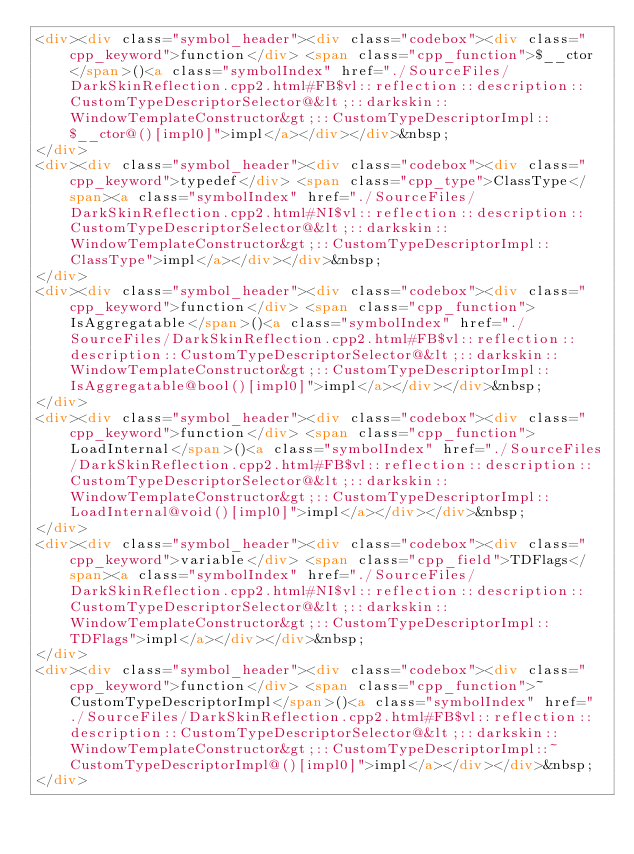Convert code to text. <code><loc_0><loc_0><loc_500><loc_500><_HTML_><div><div class="symbol_header"><div class="codebox"><div class="cpp_keyword">function</div> <span class="cpp_function">$__ctor</span>()<a class="symbolIndex" href="./SourceFiles/DarkSkinReflection.cpp2.html#FB$vl::reflection::description::CustomTypeDescriptorSelector@&lt;::darkskin::WindowTemplateConstructor&gt;::CustomTypeDescriptorImpl::$__ctor@()[impl0]">impl</a></div></div>&nbsp;
</div>
<div><div class="symbol_header"><div class="codebox"><div class="cpp_keyword">typedef</div> <span class="cpp_type">ClassType</span><a class="symbolIndex" href="./SourceFiles/DarkSkinReflection.cpp2.html#NI$vl::reflection::description::CustomTypeDescriptorSelector@&lt;::darkskin::WindowTemplateConstructor&gt;::CustomTypeDescriptorImpl::ClassType">impl</a></div></div>&nbsp;
</div>
<div><div class="symbol_header"><div class="codebox"><div class="cpp_keyword">function</div> <span class="cpp_function">IsAggregatable</span>()<a class="symbolIndex" href="./SourceFiles/DarkSkinReflection.cpp2.html#FB$vl::reflection::description::CustomTypeDescriptorSelector@&lt;::darkskin::WindowTemplateConstructor&gt;::CustomTypeDescriptorImpl::IsAggregatable@bool()[impl0]">impl</a></div></div>&nbsp;
</div>
<div><div class="symbol_header"><div class="codebox"><div class="cpp_keyword">function</div> <span class="cpp_function">LoadInternal</span>()<a class="symbolIndex" href="./SourceFiles/DarkSkinReflection.cpp2.html#FB$vl::reflection::description::CustomTypeDescriptorSelector@&lt;::darkskin::WindowTemplateConstructor&gt;::CustomTypeDescriptorImpl::LoadInternal@void()[impl0]">impl</a></div></div>&nbsp;
</div>
<div><div class="symbol_header"><div class="codebox"><div class="cpp_keyword">variable</div> <span class="cpp_field">TDFlags</span><a class="symbolIndex" href="./SourceFiles/DarkSkinReflection.cpp2.html#NI$vl::reflection::description::CustomTypeDescriptorSelector@&lt;::darkskin::WindowTemplateConstructor&gt;::CustomTypeDescriptorImpl::TDFlags">impl</a></div></div>&nbsp;
</div>
<div><div class="symbol_header"><div class="codebox"><div class="cpp_keyword">function</div> <span class="cpp_function">~CustomTypeDescriptorImpl</span>()<a class="symbolIndex" href="./SourceFiles/DarkSkinReflection.cpp2.html#FB$vl::reflection::description::CustomTypeDescriptorSelector@&lt;::darkskin::WindowTemplateConstructor&gt;::CustomTypeDescriptorImpl::~CustomTypeDescriptorImpl@()[impl0]">impl</a></div></div>&nbsp;
</div>
</code> 